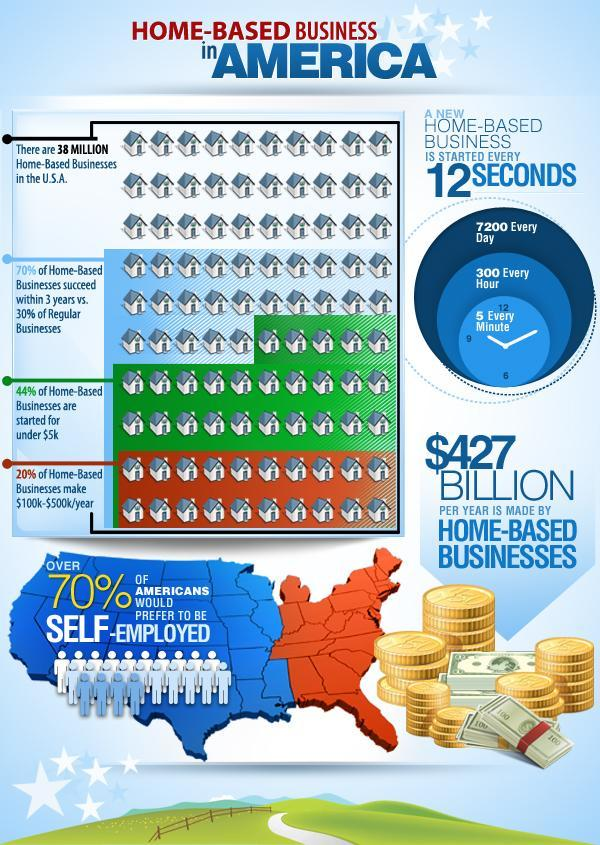how many home-based businesses have been started in every two minutes?
Answer the question with a short phrase. 10 what is the choice of most of the Americans, to be self employed or any other jobs? to be self employed what percent of home based businesses are making less than $100K or greater than $500K per year? 80% what percentage of home-based businesses are not started for under $5K? 56 